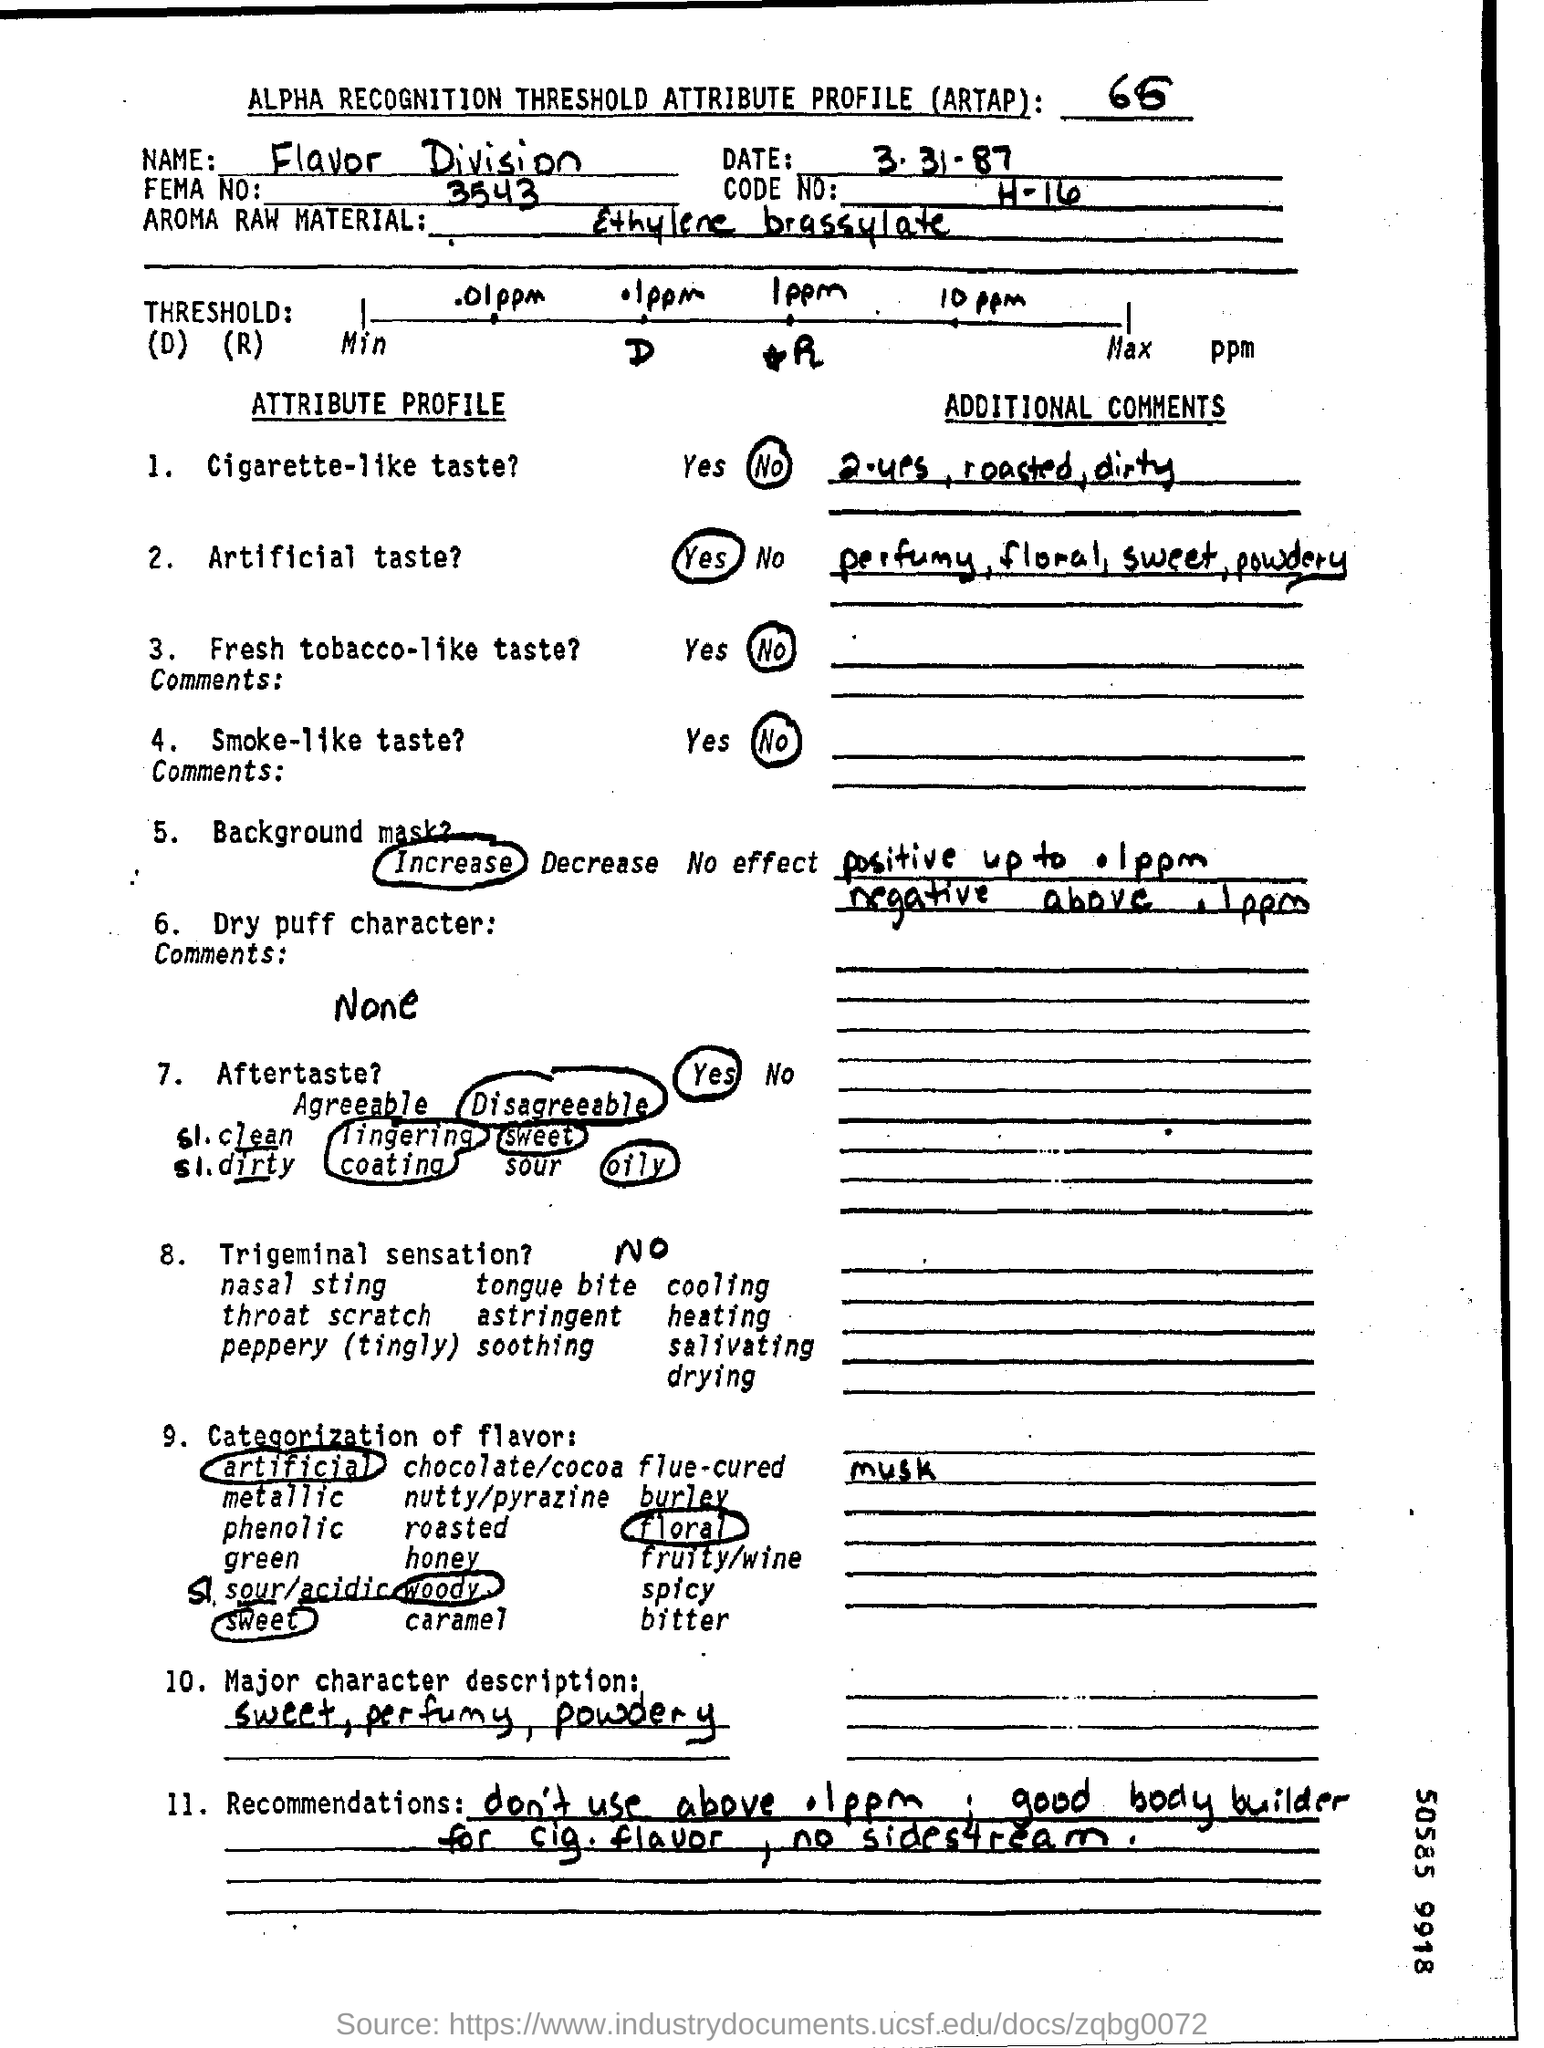What is the name mentioned in the document?
Make the answer very short. Flavor division. What is the date mentioned?
Give a very brief answer. 3-31-87. 